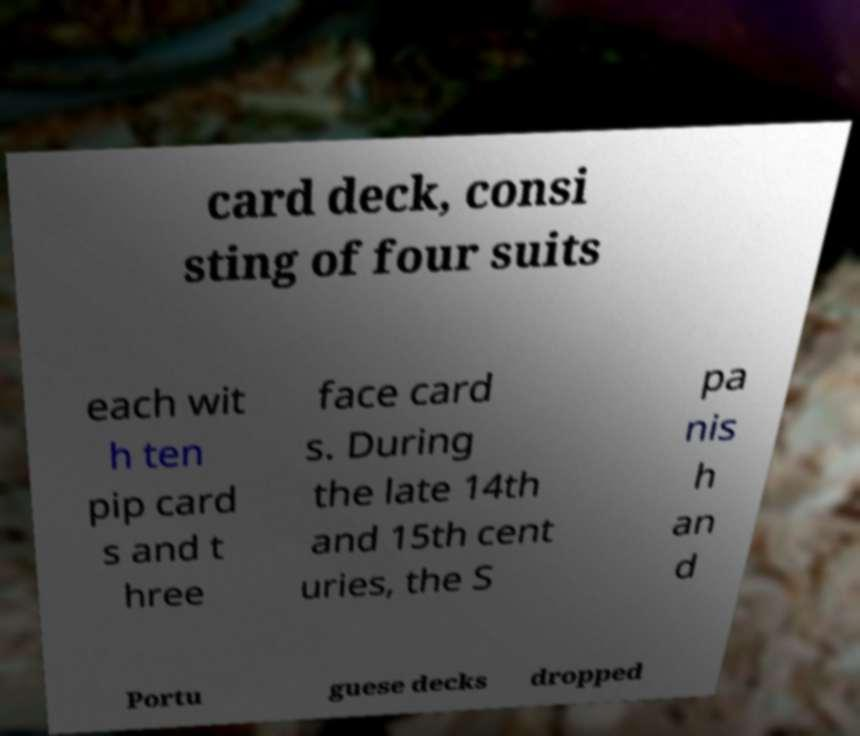For documentation purposes, I need the text within this image transcribed. Could you provide that? card deck, consi sting of four suits each wit h ten pip card s and t hree face card s. During the late 14th and 15th cent uries, the S pa nis h an d Portu guese decks dropped 